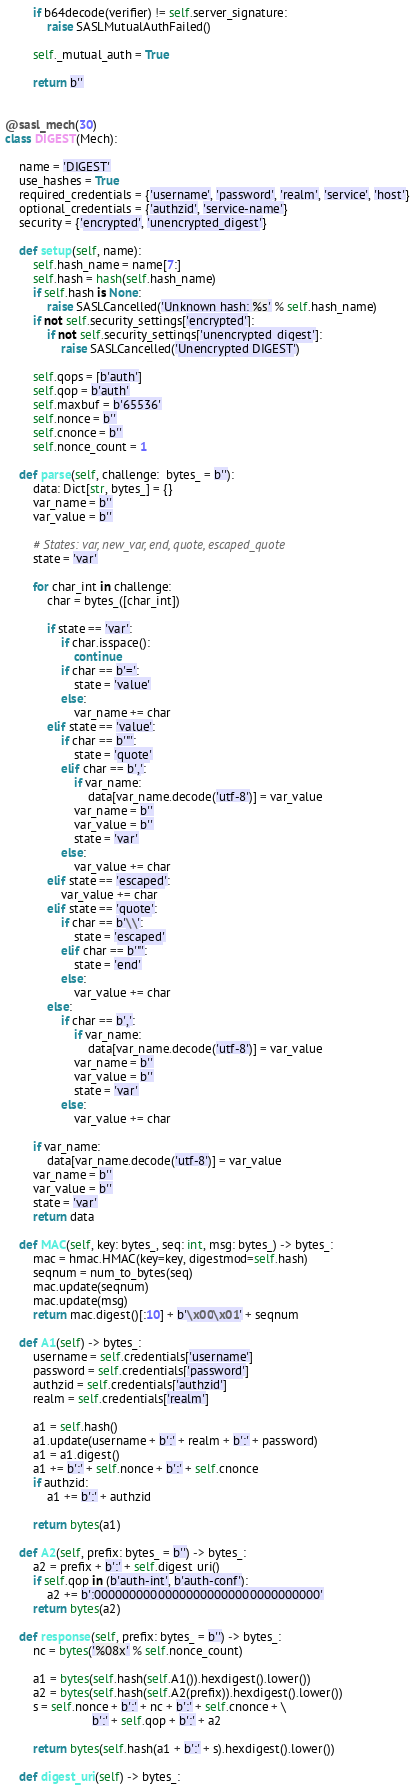Convert code to text. <code><loc_0><loc_0><loc_500><loc_500><_Python_>        if b64decode(verifier) != self.server_signature:
            raise SASLMutualAuthFailed()

        self._mutual_auth = True

        return b''


@sasl_mech(30)
class DIGEST(Mech):

    name = 'DIGEST'
    use_hashes = True
    required_credentials = {'username', 'password', 'realm', 'service', 'host'}
    optional_credentials = {'authzid', 'service-name'}
    security = {'encrypted', 'unencrypted_digest'}

    def setup(self, name):
        self.hash_name = name[7:]
        self.hash = hash(self.hash_name)
        if self.hash is None:
            raise SASLCancelled('Unknown hash: %s' % self.hash_name)
        if not self.security_settings['encrypted']:
            if not self.security_settings['unencrypted_digest']:
                raise SASLCancelled('Unencrypted DIGEST')

        self.qops = [b'auth']
        self.qop = b'auth'
        self.maxbuf = b'65536'
        self.nonce = b''
        self.cnonce = b''
        self.nonce_count = 1

    def parse(self, challenge:  bytes_ = b''):
        data: Dict[str, bytes_] = {}
        var_name = b''
        var_value = b''

        # States: var, new_var, end, quote, escaped_quote
        state = 'var'

        for char_int in challenge:
            char = bytes_([char_int])

            if state == 'var':
                if char.isspace():
                    continue
                if char == b'=':
                    state = 'value'
                else:
                    var_name += char
            elif state == 'value':
                if char == b'"':
                    state = 'quote'
                elif char == b',':
                    if var_name:
                        data[var_name.decode('utf-8')] = var_value
                    var_name = b''
                    var_value = b''
                    state = 'var'
                else:
                    var_value += char
            elif state == 'escaped':
                var_value += char
            elif state == 'quote':
                if char == b'\\':
                    state = 'escaped'
                elif char == b'"':
                    state = 'end'
                else:
                    var_value += char
            else:
                if char == b',':
                    if var_name:
                        data[var_name.decode('utf-8')] = var_value
                    var_name = b''
                    var_value = b''
                    state = 'var'
                else:
                    var_value += char

        if var_name:
            data[var_name.decode('utf-8')] = var_value
        var_name = b''
        var_value = b''
        state = 'var'
        return data

    def MAC(self, key: bytes_, seq: int, msg: bytes_) -> bytes_:
        mac = hmac.HMAC(key=key, digestmod=self.hash)
        seqnum = num_to_bytes(seq)
        mac.update(seqnum)
        mac.update(msg)
        return mac.digest()[:10] + b'\x00\x01' + seqnum

    def A1(self) -> bytes_:
        username = self.credentials['username']
        password = self.credentials['password']
        authzid = self.credentials['authzid']
        realm = self.credentials['realm']

        a1 = self.hash()
        a1.update(username + b':' + realm + b':' + password)
        a1 = a1.digest()
        a1 += b':' + self.nonce + b':' + self.cnonce
        if authzid:
            a1 += b':' + authzid

        return bytes(a1)

    def A2(self, prefix: bytes_ = b'') -> bytes_:
        a2 = prefix + b':' + self.digest_uri()
        if self.qop in (b'auth-int', b'auth-conf'):
            a2 += b':00000000000000000000000000000000'
        return bytes(a2)

    def response(self, prefix: bytes_ = b'') -> bytes_:
        nc = bytes('%08x' % self.nonce_count)

        a1 = bytes(self.hash(self.A1()).hexdigest().lower())
        a2 = bytes(self.hash(self.A2(prefix)).hexdigest().lower())
        s = self.nonce + b':' + nc + b':' + self.cnonce + \
                         b':' + self.qop + b':' + a2

        return bytes(self.hash(a1 + b':' + s).hexdigest().lower())

    def digest_uri(self) -> bytes_:</code> 